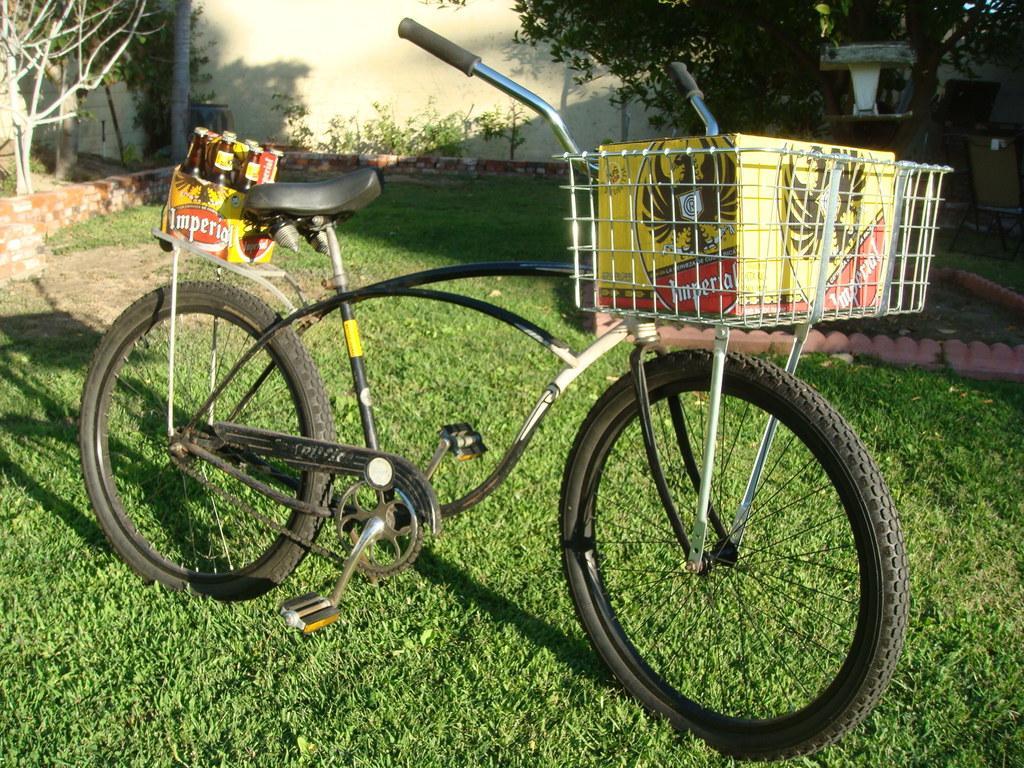How would you summarize this image in a sentence or two? In the image we can see a bicycle. There are bottles and a box, grass, plant, wall, pole and trees. We can even see there are chairs. 